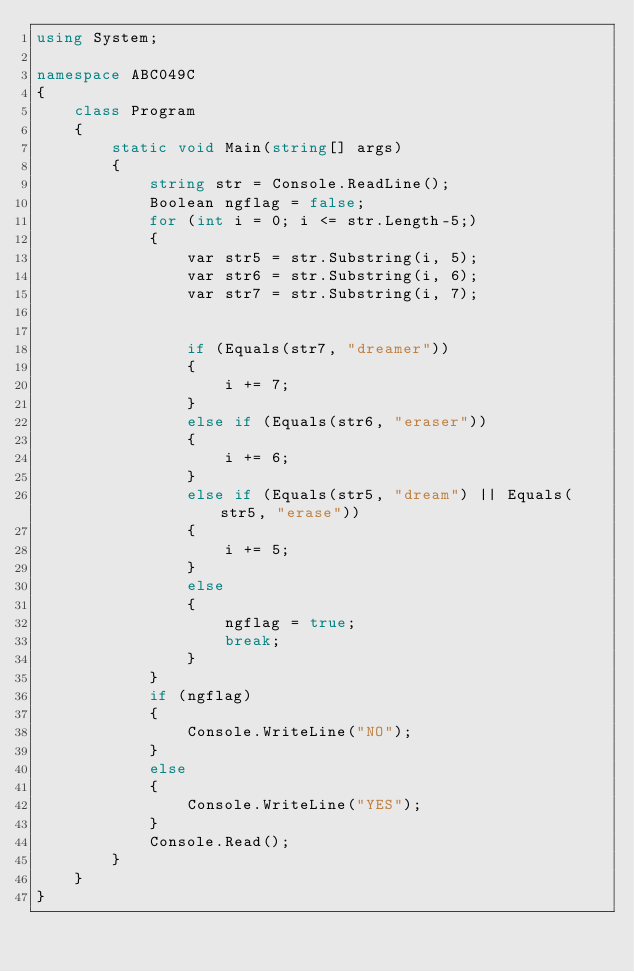<code> <loc_0><loc_0><loc_500><loc_500><_C#_>using System;

namespace ABC049C
{
    class Program
    {
        static void Main(string[] args)
        {
            string str = Console.ReadLine();
            Boolean ngflag = false;
            for (int i = 0; i <= str.Length-5;)
            {
                var str5 = str.Substring(i, 5);
                var str6 = str.Substring(i, 6);
                var str7 = str.Substring(i, 7);


                if (Equals(str7, "dreamer"))
                {
                    i += 7;
                }
                else if (Equals(str6, "eraser"))
                {
                    i += 6;
                }
                else if (Equals(str5, "dream") || Equals(str5, "erase"))
                {
                    i += 5;
                }
                else
                {
                    ngflag = true;
                    break;
                }
            }
            if (ngflag)
            {
                Console.WriteLine("NO");
            }
            else
            {
                Console.WriteLine("YES");
            }
            Console.Read();
        }
    }
}
</code> 